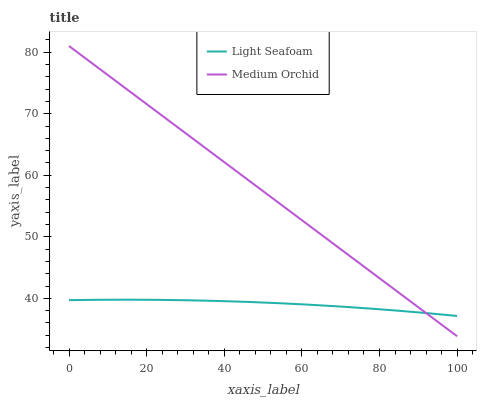Does Light Seafoam have the minimum area under the curve?
Answer yes or no. Yes. Does Medium Orchid have the maximum area under the curve?
Answer yes or no. Yes. Does Light Seafoam have the maximum area under the curve?
Answer yes or no. No. Is Medium Orchid the smoothest?
Answer yes or no. Yes. Is Light Seafoam the roughest?
Answer yes or no. Yes. Is Light Seafoam the smoothest?
Answer yes or no. No. Does Medium Orchid have the lowest value?
Answer yes or no. Yes. Does Light Seafoam have the lowest value?
Answer yes or no. No. Does Medium Orchid have the highest value?
Answer yes or no. Yes. Does Light Seafoam have the highest value?
Answer yes or no. No. Does Light Seafoam intersect Medium Orchid?
Answer yes or no. Yes. Is Light Seafoam less than Medium Orchid?
Answer yes or no. No. Is Light Seafoam greater than Medium Orchid?
Answer yes or no. No. 